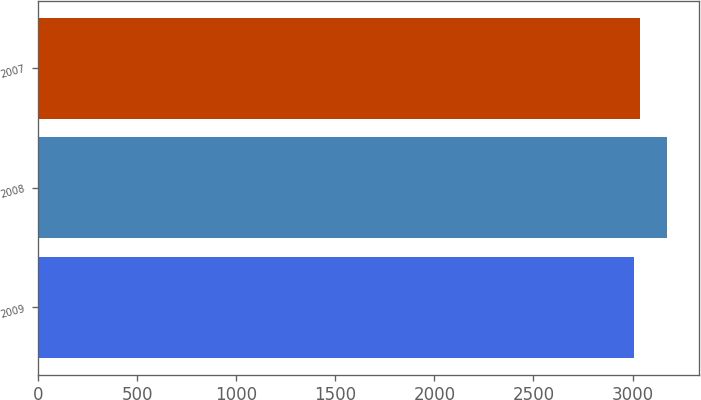<chart> <loc_0><loc_0><loc_500><loc_500><bar_chart><fcel>2009<fcel>2008<fcel>2007<nl><fcel>3007<fcel>3174<fcel>3039<nl></chart> 